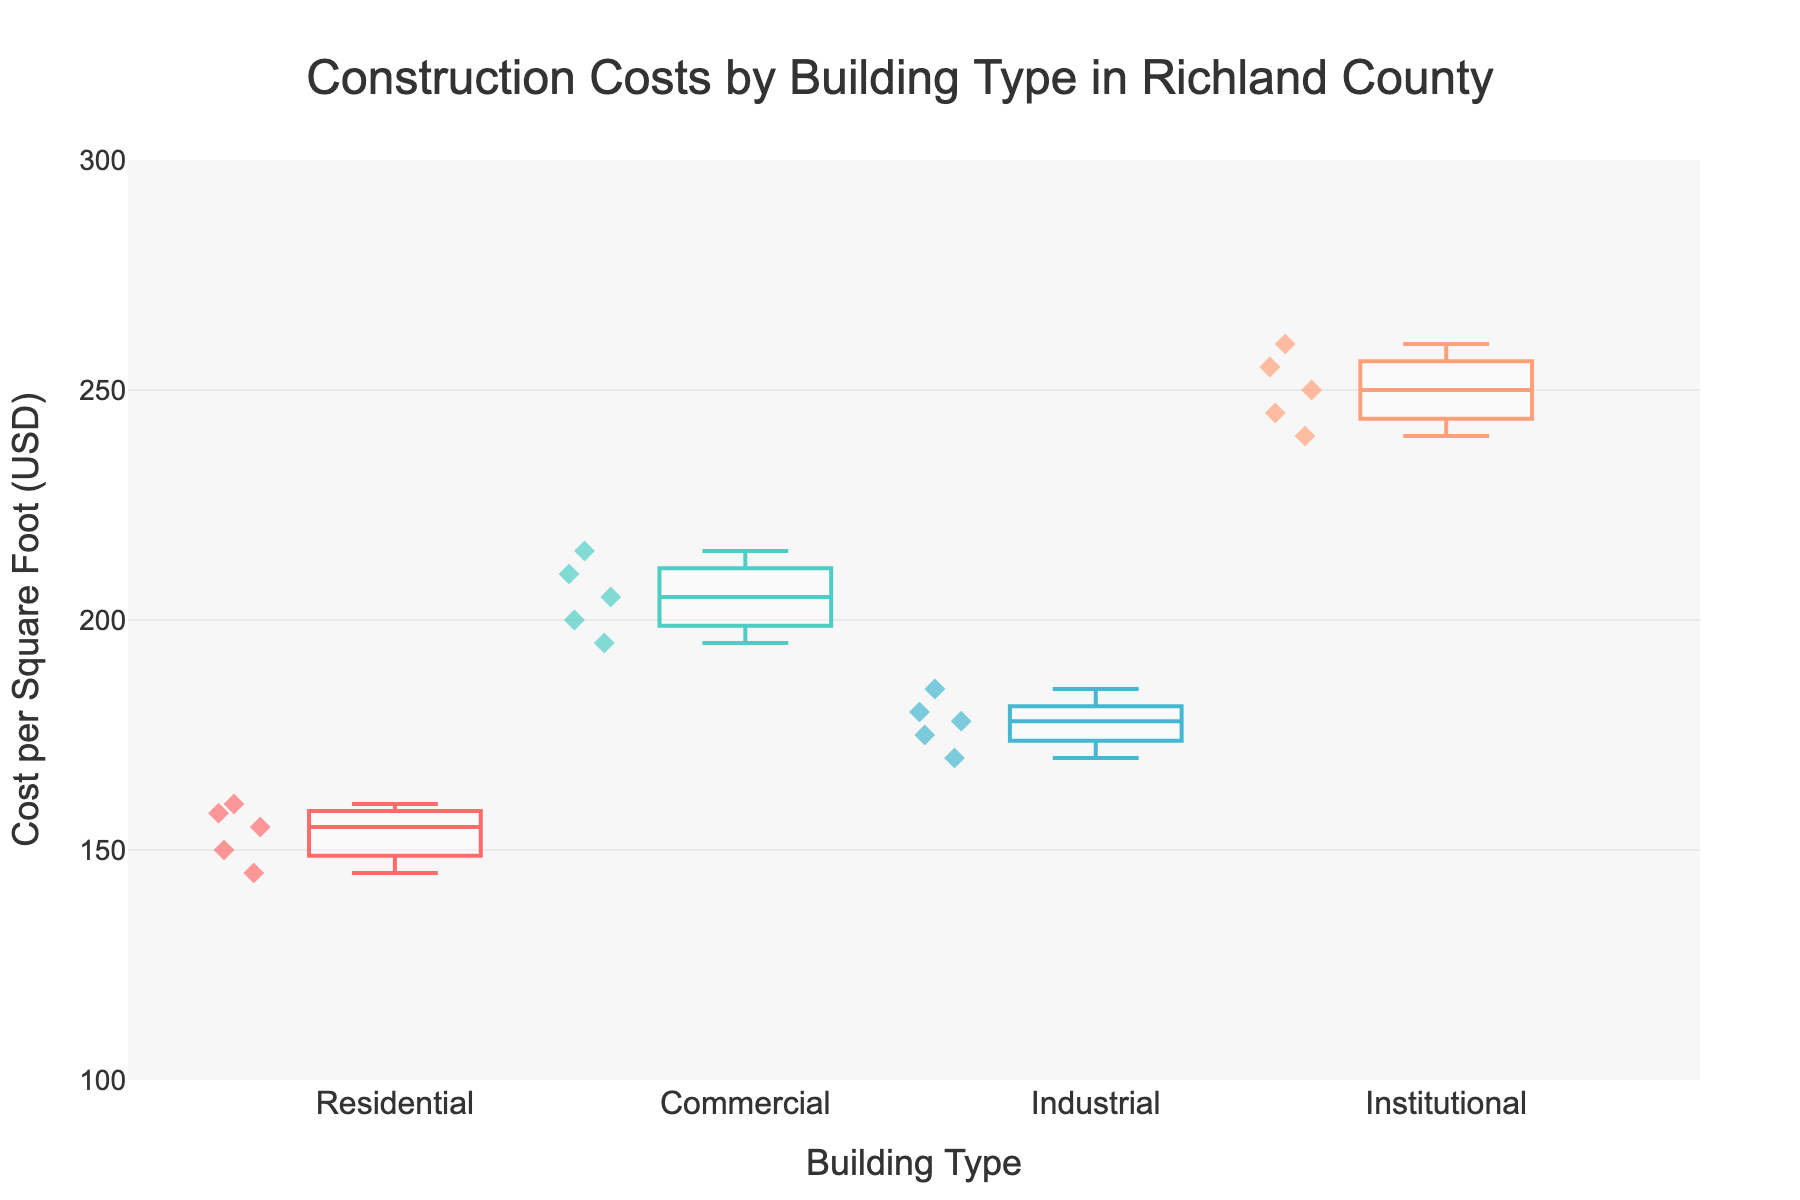What is the title of the figure? The title is displayed at the top center of the figure, which typically summarises the content.
Answer: Construction Costs by Building Type in Richland County What is the vertical axis representing? The text label on the vertical axis specifies what is being measured; it reads "Cost per Square Foot (USD)."
Answer: Cost per Square Foot (USD) What are the building types included in the figure? The distinct box plots on the horizontal axis each represent a specific building type.
Answer: Residential, Commercial, Industrial, Institutional Which building type has the highest median construction cost per square foot? By inspecting the median lines in the box plots, we can see which one is highest. The median is the line inside the box.
Answer: Institutional What is the interquartile range (IQR) for Residential building type? The IQR is defined as the range between the first quartile (Q1) and the third quartile (Q3) in the box plot. For Residential, Q1 is approximately 150 and Q3 is approximately 158.
Answer: 8 How does the variability in construction costs compare between Commercial and Industrial buildings? By examining the spread of the box plots for each type, we see that the Commercial buildings have a wider range of costs compared to Industrial buildings.
Answer: Commercial has higher variability Which building type has the lowest minimum construction cost per square foot? The minimum value is identified by the lowest point in the box plot's whiskers.
Answer: Residential Calculate the median construction cost per square foot for Commercial and Industrial and compare. The median for Commercial is around 205, while the median for Industrial is around 178; comparing these, Commercial has a higher median.
Answer: Commercial > Industrial Are there any outliers in the Institutional building type data? Outliers are marked as individual points that fall outside the whiskers of the box plot.
Answer: No Rank the building types from most to least expensive in terms of median construction cost. Order the building types based on the heights of their median lines from highest to lowest.
Answer: Institutional, Commercial, Industrial, Residential 